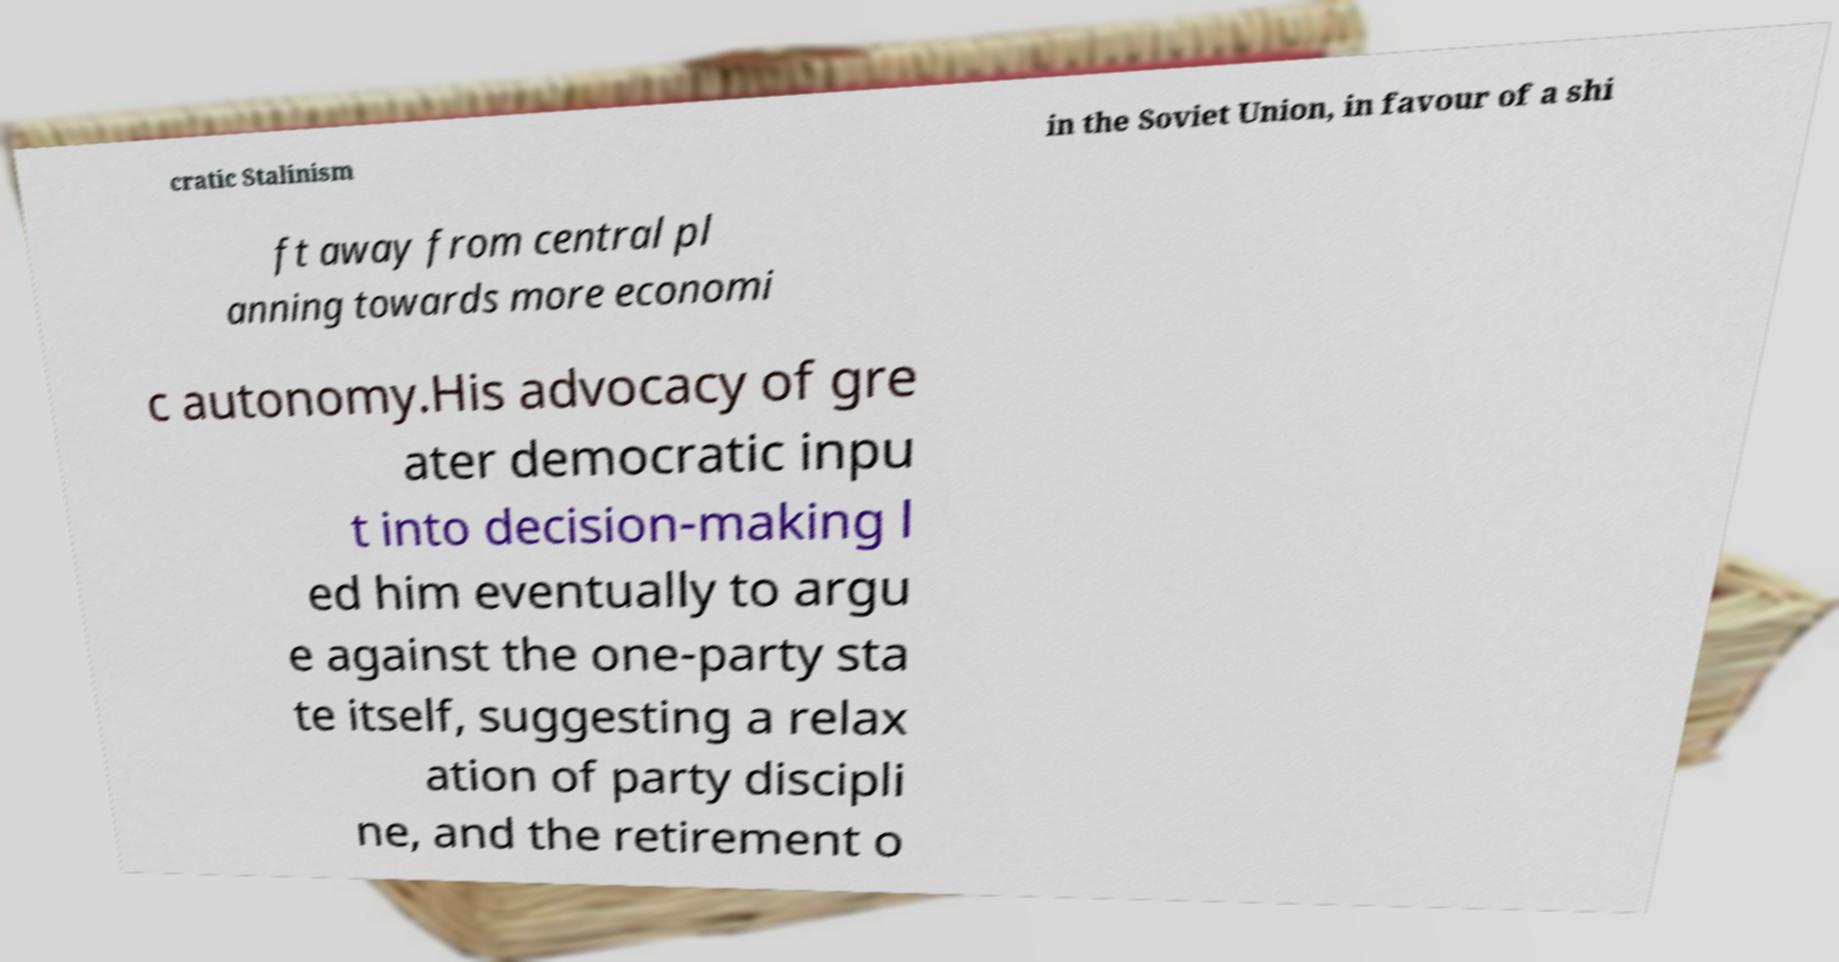For documentation purposes, I need the text within this image transcribed. Could you provide that? cratic Stalinism in the Soviet Union, in favour of a shi ft away from central pl anning towards more economi c autonomy.His advocacy of gre ater democratic inpu t into decision-making l ed him eventually to argu e against the one-party sta te itself, suggesting a relax ation of party discipli ne, and the retirement o 